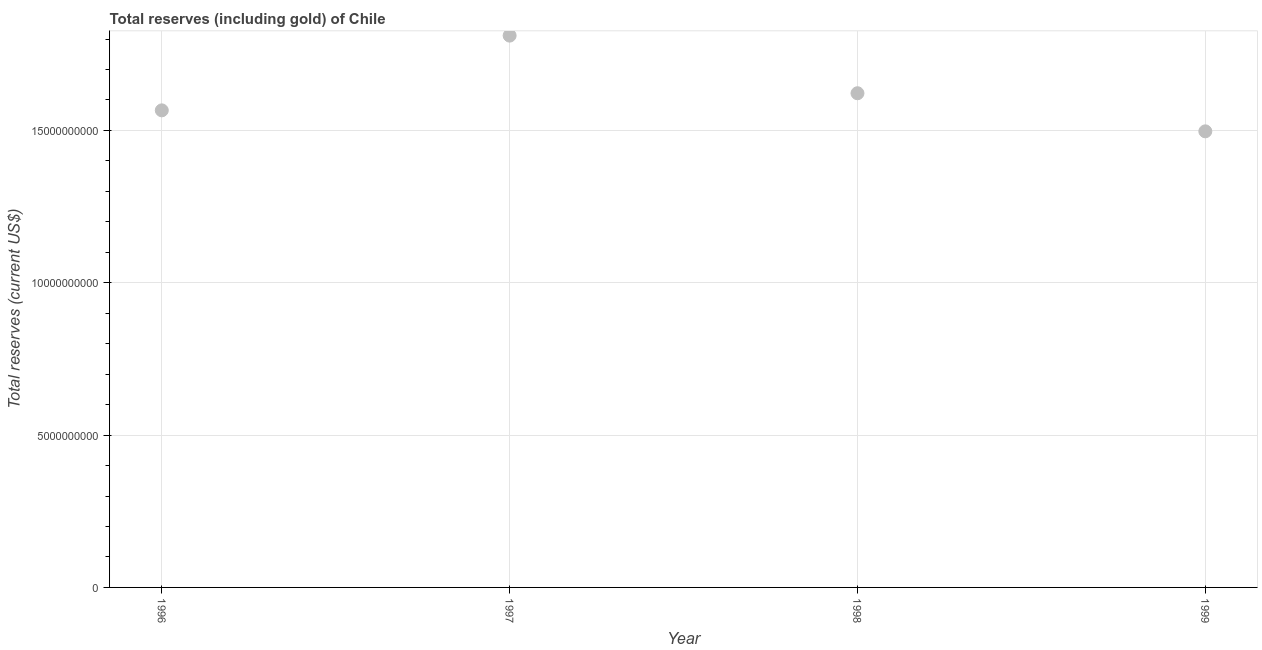What is the total reserves (including gold) in 1997?
Provide a succinct answer. 1.81e+1. Across all years, what is the maximum total reserves (including gold)?
Keep it short and to the point. 1.81e+1. Across all years, what is the minimum total reserves (including gold)?
Keep it short and to the point. 1.50e+1. In which year was the total reserves (including gold) maximum?
Give a very brief answer. 1997. In which year was the total reserves (including gold) minimum?
Offer a very short reply. 1999. What is the sum of the total reserves (including gold)?
Your response must be concise. 6.50e+1. What is the difference between the total reserves (including gold) in 1998 and 1999?
Provide a succinct answer. 1.25e+09. What is the average total reserves (including gold) per year?
Your answer should be compact. 1.62e+1. What is the median total reserves (including gold)?
Your answer should be compact. 1.59e+1. In how many years, is the total reserves (including gold) greater than 13000000000 US$?
Make the answer very short. 4. Do a majority of the years between 1996 and 1998 (inclusive) have total reserves (including gold) greater than 1000000000 US$?
Your answer should be compact. Yes. What is the ratio of the total reserves (including gold) in 1996 to that in 1997?
Ensure brevity in your answer.  0.86. Is the total reserves (including gold) in 1997 less than that in 1999?
Offer a terse response. No. Is the difference between the total reserves (including gold) in 1996 and 1999 greater than the difference between any two years?
Your response must be concise. No. What is the difference between the highest and the second highest total reserves (including gold)?
Keep it short and to the point. 1.89e+09. What is the difference between the highest and the lowest total reserves (including gold)?
Offer a very short reply. 3.14e+09. What is the title of the graph?
Offer a terse response. Total reserves (including gold) of Chile. What is the label or title of the Y-axis?
Provide a succinct answer. Total reserves (current US$). What is the Total reserves (current US$) in 1996?
Offer a terse response. 1.57e+1. What is the Total reserves (current US$) in 1997?
Give a very brief answer. 1.81e+1. What is the Total reserves (current US$) in 1998?
Ensure brevity in your answer.  1.62e+1. What is the Total reserves (current US$) in 1999?
Offer a terse response. 1.50e+1. What is the difference between the Total reserves (current US$) in 1996 and 1997?
Provide a short and direct response. -2.45e+09. What is the difference between the Total reserves (current US$) in 1996 and 1998?
Provide a short and direct response. -5.62e+08. What is the difference between the Total reserves (current US$) in 1996 and 1999?
Make the answer very short. 6.89e+08. What is the difference between the Total reserves (current US$) in 1997 and 1998?
Your response must be concise. 1.89e+09. What is the difference between the Total reserves (current US$) in 1997 and 1999?
Keep it short and to the point. 3.14e+09. What is the difference between the Total reserves (current US$) in 1998 and 1999?
Provide a succinct answer. 1.25e+09. What is the ratio of the Total reserves (current US$) in 1996 to that in 1997?
Offer a very short reply. 0.86. What is the ratio of the Total reserves (current US$) in 1996 to that in 1999?
Provide a short and direct response. 1.05. What is the ratio of the Total reserves (current US$) in 1997 to that in 1998?
Keep it short and to the point. 1.12. What is the ratio of the Total reserves (current US$) in 1997 to that in 1999?
Provide a short and direct response. 1.21. What is the ratio of the Total reserves (current US$) in 1998 to that in 1999?
Provide a succinct answer. 1.08. 